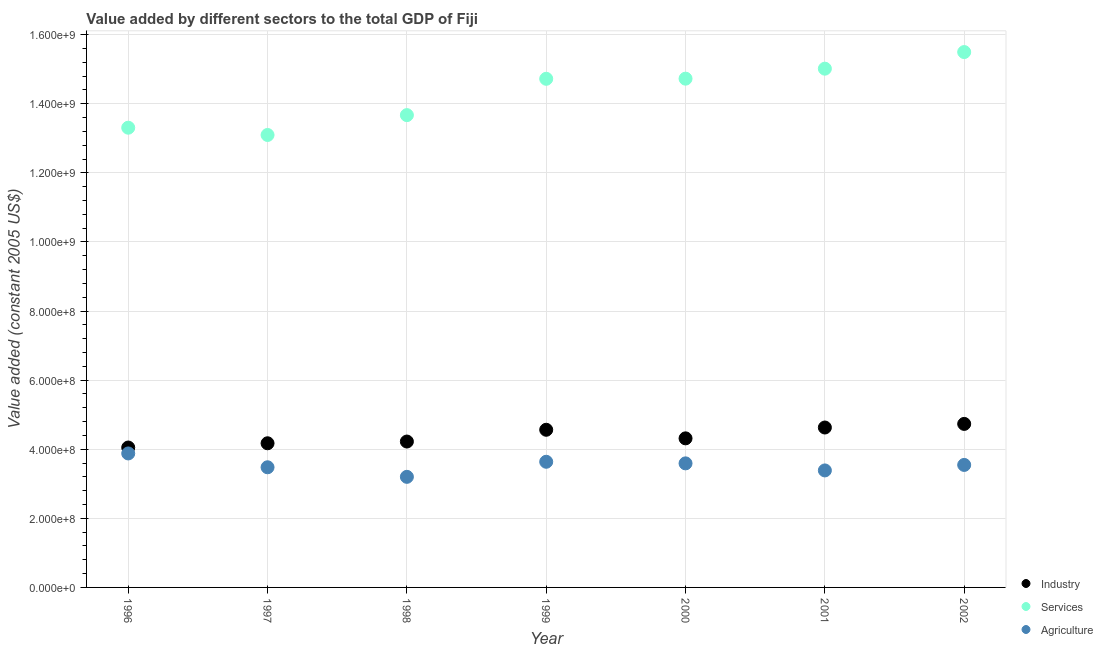How many different coloured dotlines are there?
Give a very brief answer. 3. Is the number of dotlines equal to the number of legend labels?
Offer a very short reply. Yes. What is the value added by services in 2000?
Offer a very short reply. 1.47e+09. Across all years, what is the maximum value added by agricultural sector?
Give a very brief answer. 3.88e+08. Across all years, what is the minimum value added by agricultural sector?
Your answer should be compact. 3.20e+08. In which year was the value added by industrial sector minimum?
Keep it short and to the point. 1996. What is the total value added by services in the graph?
Your answer should be compact. 1.00e+1. What is the difference between the value added by agricultural sector in 1996 and that in 2001?
Provide a short and direct response. 4.91e+07. What is the difference between the value added by services in 1999 and the value added by industrial sector in 2000?
Offer a very short reply. 1.04e+09. What is the average value added by industrial sector per year?
Your answer should be very brief. 4.38e+08. In the year 1999, what is the difference between the value added by industrial sector and value added by services?
Offer a very short reply. -1.02e+09. In how many years, is the value added by services greater than 200000000 US$?
Provide a succinct answer. 7. What is the ratio of the value added by industrial sector in 1996 to that in 2000?
Make the answer very short. 0.94. What is the difference between the highest and the second highest value added by services?
Your answer should be very brief. 4.81e+07. What is the difference between the highest and the lowest value added by industrial sector?
Keep it short and to the point. 6.84e+07. In how many years, is the value added by industrial sector greater than the average value added by industrial sector taken over all years?
Provide a short and direct response. 3. Is the sum of the value added by services in 1998 and 2001 greater than the maximum value added by industrial sector across all years?
Give a very brief answer. Yes. Is the value added by services strictly greater than the value added by agricultural sector over the years?
Provide a succinct answer. Yes. How many years are there in the graph?
Give a very brief answer. 7. What is the difference between two consecutive major ticks on the Y-axis?
Keep it short and to the point. 2.00e+08. Are the values on the major ticks of Y-axis written in scientific E-notation?
Your response must be concise. Yes. Does the graph contain grids?
Make the answer very short. Yes. Where does the legend appear in the graph?
Provide a succinct answer. Bottom right. How many legend labels are there?
Your answer should be very brief. 3. How are the legend labels stacked?
Make the answer very short. Vertical. What is the title of the graph?
Your response must be concise. Value added by different sectors to the total GDP of Fiji. What is the label or title of the Y-axis?
Provide a succinct answer. Value added (constant 2005 US$). What is the Value added (constant 2005 US$) in Industry in 1996?
Your response must be concise. 4.05e+08. What is the Value added (constant 2005 US$) in Services in 1996?
Your answer should be compact. 1.33e+09. What is the Value added (constant 2005 US$) in Agriculture in 1996?
Ensure brevity in your answer.  3.88e+08. What is the Value added (constant 2005 US$) in Industry in 1997?
Your response must be concise. 4.17e+08. What is the Value added (constant 2005 US$) of Services in 1997?
Keep it short and to the point. 1.31e+09. What is the Value added (constant 2005 US$) in Agriculture in 1997?
Offer a very short reply. 3.48e+08. What is the Value added (constant 2005 US$) of Industry in 1998?
Your response must be concise. 4.22e+08. What is the Value added (constant 2005 US$) of Services in 1998?
Offer a very short reply. 1.37e+09. What is the Value added (constant 2005 US$) in Agriculture in 1998?
Give a very brief answer. 3.20e+08. What is the Value added (constant 2005 US$) in Industry in 1999?
Ensure brevity in your answer.  4.56e+08. What is the Value added (constant 2005 US$) of Services in 1999?
Offer a terse response. 1.47e+09. What is the Value added (constant 2005 US$) of Agriculture in 1999?
Make the answer very short. 3.64e+08. What is the Value added (constant 2005 US$) of Industry in 2000?
Offer a terse response. 4.31e+08. What is the Value added (constant 2005 US$) in Services in 2000?
Your answer should be very brief. 1.47e+09. What is the Value added (constant 2005 US$) of Agriculture in 2000?
Your response must be concise. 3.59e+08. What is the Value added (constant 2005 US$) of Industry in 2001?
Offer a terse response. 4.63e+08. What is the Value added (constant 2005 US$) in Services in 2001?
Keep it short and to the point. 1.50e+09. What is the Value added (constant 2005 US$) of Agriculture in 2001?
Make the answer very short. 3.39e+08. What is the Value added (constant 2005 US$) of Industry in 2002?
Provide a succinct answer. 4.73e+08. What is the Value added (constant 2005 US$) in Services in 2002?
Ensure brevity in your answer.  1.55e+09. What is the Value added (constant 2005 US$) in Agriculture in 2002?
Provide a short and direct response. 3.55e+08. Across all years, what is the maximum Value added (constant 2005 US$) of Industry?
Offer a very short reply. 4.73e+08. Across all years, what is the maximum Value added (constant 2005 US$) in Services?
Your answer should be compact. 1.55e+09. Across all years, what is the maximum Value added (constant 2005 US$) in Agriculture?
Give a very brief answer. 3.88e+08. Across all years, what is the minimum Value added (constant 2005 US$) in Industry?
Provide a short and direct response. 4.05e+08. Across all years, what is the minimum Value added (constant 2005 US$) in Services?
Offer a terse response. 1.31e+09. Across all years, what is the minimum Value added (constant 2005 US$) of Agriculture?
Offer a terse response. 3.20e+08. What is the total Value added (constant 2005 US$) in Industry in the graph?
Provide a succinct answer. 3.07e+09. What is the total Value added (constant 2005 US$) in Services in the graph?
Offer a very short reply. 1.00e+1. What is the total Value added (constant 2005 US$) of Agriculture in the graph?
Your response must be concise. 2.47e+09. What is the difference between the Value added (constant 2005 US$) of Industry in 1996 and that in 1997?
Give a very brief answer. -1.23e+07. What is the difference between the Value added (constant 2005 US$) in Services in 1996 and that in 1997?
Offer a terse response. 2.11e+07. What is the difference between the Value added (constant 2005 US$) in Agriculture in 1996 and that in 1997?
Your answer should be compact. 4.00e+07. What is the difference between the Value added (constant 2005 US$) of Industry in 1996 and that in 1998?
Offer a terse response. -1.73e+07. What is the difference between the Value added (constant 2005 US$) in Services in 1996 and that in 1998?
Provide a succinct answer. -3.64e+07. What is the difference between the Value added (constant 2005 US$) of Agriculture in 1996 and that in 1998?
Your response must be concise. 6.77e+07. What is the difference between the Value added (constant 2005 US$) of Industry in 1996 and that in 1999?
Your answer should be very brief. -5.14e+07. What is the difference between the Value added (constant 2005 US$) in Services in 1996 and that in 1999?
Provide a succinct answer. -1.42e+08. What is the difference between the Value added (constant 2005 US$) in Agriculture in 1996 and that in 1999?
Your response must be concise. 2.41e+07. What is the difference between the Value added (constant 2005 US$) in Industry in 1996 and that in 2000?
Your response must be concise. -2.65e+07. What is the difference between the Value added (constant 2005 US$) in Services in 1996 and that in 2000?
Provide a succinct answer. -1.42e+08. What is the difference between the Value added (constant 2005 US$) of Agriculture in 1996 and that in 2000?
Provide a short and direct response. 2.87e+07. What is the difference between the Value added (constant 2005 US$) of Industry in 1996 and that in 2001?
Offer a very short reply. -5.79e+07. What is the difference between the Value added (constant 2005 US$) in Services in 1996 and that in 2001?
Provide a short and direct response. -1.71e+08. What is the difference between the Value added (constant 2005 US$) in Agriculture in 1996 and that in 2001?
Keep it short and to the point. 4.91e+07. What is the difference between the Value added (constant 2005 US$) of Industry in 1996 and that in 2002?
Make the answer very short. -6.84e+07. What is the difference between the Value added (constant 2005 US$) of Services in 1996 and that in 2002?
Make the answer very short. -2.19e+08. What is the difference between the Value added (constant 2005 US$) of Agriculture in 1996 and that in 2002?
Offer a very short reply. 3.32e+07. What is the difference between the Value added (constant 2005 US$) in Industry in 1997 and that in 1998?
Your answer should be compact. -5.03e+06. What is the difference between the Value added (constant 2005 US$) of Services in 1997 and that in 1998?
Provide a short and direct response. -5.75e+07. What is the difference between the Value added (constant 2005 US$) in Agriculture in 1997 and that in 1998?
Give a very brief answer. 2.77e+07. What is the difference between the Value added (constant 2005 US$) in Industry in 1997 and that in 1999?
Provide a short and direct response. -3.91e+07. What is the difference between the Value added (constant 2005 US$) in Services in 1997 and that in 1999?
Give a very brief answer. -1.63e+08. What is the difference between the Value added (constant 2005 US$) in Agriculture in 1997 and that in 1999?
Make the answer very short. -1.59e+07. What is the difference between the Value added (constant 2005 US$) in Industry in 1997 and that in 2000?
Your answer should be compact. -1.42e+07. What is the difference between the Value added (constant 2005 US$) of Services in 1997 and that in 2000?
Give a very brief answer. -1.63e+08. What is the difference between the Value added (constant 2005 US$) of Agriculture in 1997 and that in 2000?
Your answer should be compact. -1.13e+07. What is the difference between the Value added (constant 2005 US$) in Industry in 1997 and that in 2001?
Make the answer very short. -4.56e+07. What is the difference between the Value added (constant 2005 US$) of Services in 1997 and that in 2001?
Provide a succinct answer. -1.92e+08. What is the difference between the Value added (constant 2005 US$) of Agriculture in 1997 and that in 2001?
Your response must be concise. 9.13e+06. What is the difference between the Value added (constant 2005 US$) in Industry in 1997 and that in 2002?
Your response must be concise. -5.61e+07. What is the difference between the Value added (constant 2005 US$) in Services in 1997 and that in 2002?
Ensure brevity in your answer.  -2.40e+08. What is the difference between the Value added (constant 2005 US$) of Agriculture in 1997 and that in 2002?
Give a very brief answer. -6.79e+06. What is the difference between the Value added (constant 2005 US$) of Industry in 1998 and that in 1999?
Give a very brief answer. -3.41e+07. What is the difference between the Value added (constant 2005 US$) in Services in 1998 and that in 1999?
Offer a very short reply. -1.05e+08. What is the difference between the Value added (constant 2005 US$) in Agriculture in 1998 and that in 1999?
Make the answer very short. -4.36e+07. What is the difference between the Value added (constant 2005 US$) of Industry in 1998 and that in 2000?
Offer a very short reply. -9.22e+06. What is the difference between the Value added (constant 2005 US$) of Services in 1998 and that in 2000?
Keep it short and to the point. -1.06e+08. What is the difference between the Value added (constant 2005 US$) in Agriculture in 1998 and that in 2000?
Keep it short and to the point. -3.90e+07. What is the difference between the Value added (constant 2005 US$) in Industry in 1998 and that in 2001?
Provide a succinct answer. -4.06e+07. What is the difference between the Value added (constant 2005 US$) in Services in 1998 and that in 2001?
Your answer should be very brief. -1.34e+08. What is the difference between the Value added (constant 2005 US$) in Agriculture in 1998 and that in 2001?
Offer a terse response. -1.86e+07. What is the difference between the Value added (constant 2005 US$) in Industry in 1998 and that in 2002?
Provide a succinct answer. -5.10e+07. What is the difference between the Value added (constant 2005 US$) in Services in 1998 and that in 2002?
Your answer should be very brief. -1.83e+08. What is the difference between the Value added (constant 2005 US$) of Agriculture in 1998 and that in 2002?
Keep it short and to the point. -3.45e+07. What is the difference between the Value added (constant 2005 US$) of Industry in 1999 and that in 2000?
Your answer should be compact. 2.48e+07. What is the difference between the Value added (constant 2005 US$) of Services in 1999 and that in 2000?
Offer a very short reply. -3.88e+05. What is the difference between the Value added (constant 2005 US$) in Agriculture in 1999 and that in 2000?
Make the answer very short. 4.60e+06. What is the difference between the Value added (constant 2005 US$) of Industry in 1999 and that in 2001?
Your answer should be very brief. -6.54e+06. What is the difference between the Value added (constant 2005 US$) in Services in 1999 and that in 2001?
Make the answer very short. -2.93e+07. What is the difference between the Value added (constant 2005 US$) of Agriculture in 1999 and that in 2001?
Provide a succinct answer. 2.50e+07. What is the difference between the Value added (constant 2005 US$) in Industry in 1999 and that in 2002?
Your answer should be compact. -1.70e+07. What is the difference between the Value added (constant 2005 US$) of Services in 1999 and that in 2002?
Your response must be concise. -7.74e+07. What is the difference between the Value added (constant 2005 US$) in Agriculture in 1999 and that in 2002?
Provide a succinct answer. 9.13e+06. What is the difference between the Value added (constant 2005 US$) of Industry in 2000 and that in 2001?
Make the answer very short. -3.14e+07. What is the difference between the Value added (constant 2005 US$) in Services in 2000 and that in 2001?
Give a very brief answer. -2.89e+07. What is the difference between the Value added (constant 2005 US$) of Agriculture in 2000 and that in 2001?
Your answer should be very brief. 2.04e+07. What is the difference between the Value added (constant 2005 US$) in Industry in 2000 and that in 2002?
Provide a short and direct response. -4.18e+07. What is the difference between the Value added (constant 2005 US$) in Services in 2000 and that in 2002?
Ensure brevity in your answer.  -7.70e+07. What is the difference between the Value added (constant 2005 US$) of Agriculture in 2000 and that in 2002?
Provide a succinct answer. 4.52e+06. What is the difference between the Value added (constant 2005 US$) of Industry in 2001 and that in 2002?
Offer a terse response. -1.05e+07. What is the difference between the Value added (constant 2005 US$) in Services in 2001 and that in 2002?
Offer a very short reply. -4.81e+07. What is the difference between the Value added (constant 2005 US$) of Agriculture in 2001 and that in 2002?
Offer a very short reply. -1.59e+07. What is the difference between the Value added (constant 2005 US$) in Industry in 1996 and the Value added (constant 2005 US$) in Services in 1997?
Make the answer very short. -9.05e+08. What is the difference between the Value added (constant 2005 US$) of Industry in 1996 and the Value added (constant 2005 US$) of Agriculture in 1997?
Offer a very short reply. 5.72e+07. What is the difference between the Value added (constant 2005 US$) of Services in 1996 and the Value added (constant 2005 US$) of Agriculture in 1997?
Your answer should be very brief. 9.83e+08. What is the difference between the Value added (constant 2005 US$) of Industry in 1996 and the Value added (constant 2005 US$) of Services in 1998?
Provide a short and direct response. -9.62e+08. What is the difference between the Value added (constant 2005 US$) in Industry in 1996 and the Value added (constant 2005 US$) in Agriculture in 1998?
Your answer should be compact. 8.49e+07. What is the difference between the Value added (constant 2005 US$) of Services in 1996 and the Value added (constant 2005 US$) of Agriculture in 1998?
Keep it short and to the point. 1.01e+09. What is the difference between the Value added (constant 2005 US$) of Industry in 1996 and the Value added (constant 2005 US$) of Services in 1999?
Offer a terse response. -1.07e+09. What is the difference between the Value added (constant 2005 US$) of Industry in 1996 and the Value added (constant 2005 US$) of Agriculture in 1999?
Your answer should be very brief. 4.13e+07. What is the difference between the Value added (constant 2005 US$) in Services in 1996 and the Value added (constant 2005 US$) in Agriculture in 1999?
Offer a very short reply. 9.67e+08. What is the difference between the Value added (constant 2005 US$) in Industry in 1996 and the Value added (constant 2005 US$) in Services in 2000?
Provide a short and direct response. -1.07e+09. What is the difference between the Value added (constant 2005 US$) in Industry in 1996 and the Value added (constant 2005 US$) in Agriculture in 2000?
Offer a very short reply. 4.59e+07. What is the difference between the Value added (constant 2005 US$) of Services in 1996 and the Value added (constant 2005 US$) of Agriculture in 2000?
Give a very brief answer. 9.72e+08. What is the difference between the Value added (constant 2005 US$) of Industry in 1996 and the Value added (constant 2005 US$) of Services in 2001?
Ensure brevity in your answer.  -1.10e+09. What is the difference between the Value added (constant 2005 US$) in Industry in 1996 and the Value added (constant 2005 US$) in Agriculture in 2001?
Your answer should be compact. 6.63e+07. What is the difference between the Value added (constant 2005 US$) of Services in 1996 and the Value added (constant 2005 US$) of Agriculture in 2001?
Provide a succinct answer. 9.92e+08. What is the difference between the Value added (constant 2005 US$) in Industry in 1996 and the Value added (constant 2005 US$) in Services in 2002?
Provide a short and direct response. -1.14e+09. What is the difference between the Value added (constant 2005 US$) of Industry in 1996 and the Value added (constant 2005 US$) of Agriculture in 2002?
Offer a very short reply. 5.04e+07. What is the difference between the Value added (constant 2005 US$) of Services in 1996 and the Value added (constant 2005 US$) of Agriculture in 2002?
Ensure brevity in your answer.  9.76e+08. What is the difference between the Value added (constant 2005 US$) of Industry in 1997 and the Value added (constant 2005 US$) of Services in 1998?
Provide a short and direct response. -9.50e+08. What is the difference between the Value added (constant 2005 US$) in Industry in 1997 and the Value added (constant 2005 US$) in Agriculture in 1998?
Provide a short and direct response. 9.72e+07. What is the difference between the Value added (constant 2005 US$) of Services in 1997 and the Value added (constant 2005 US$) of Agriculture in 1998?
Offer a very short reply. 9.90e+08. What is the difference between the Value added (constant 2005 US$) of Industry in 1997 and the Value added (constant 2005 US$) of Services in 1999?
Ensure brevity in your answer.  -1.05e+09. What is the difference between the Value added (constant 2005 US$) in Industry in 1997 and the Value added (constant 2005 US$) in Agriculture in 1999?
Keep it short and to the point. 5.36e+07. What is the difference between the Value added (constant 2005 US$) in Services in 1997 and the Value added (constant 2005 US$) in Agriculture in 1999?
Your answer should be very brief. 9.46e+08. What is the difference between the Value added (constant 2005 US$) of Industry in 1997 and the Value added (constant 2005 US$) of Services in 2000?
Make the answer very short. -1.06e+09. What is the difference between the Value added (constant 2005 US$) of Industry in 1997 and the Value added (constant 2005 US$) of Agriculture in 2000?
Make the answer very short. 5.82e+07. What is the difference between the Value added (constant 2005 US$) in Services in 1997 and the Value added (constant 2005 US$) in Agriculture in 2000?
Provide a short and direct response. 9.51e+08. What is the difference between the Value added (constant 2005 US$) of Industry in 1997 and the Value added (constant 2005 US$) of Services in 2001?
Keep it short and to the point. -1.08e+09. What is the difference between the Value added (constant 2005 US$) of Industry in 1997 and the Value added (constant 2005 US$) of Agriculture in 2001?
Keep it short and to the point. 7.86e+07. What is the difference between the Value added (constant 2005 US$) of Services in 1997 and the Value added (constant 2005 US$) of Agriculture in 2001?
Provide a succinct answer. 9.71e+08. What is the difference between the Value added (constant 2005 US$) in Industry in 1997 and the Value added (constant 2005 US$) in Services in 2002?
Provide a succinct answer. -1.13e+09. What is the difference between the Value added (constant 2005 US$) of Industry in 1997 and the Value added (constant 2005 US$) of Agriculture in 2002?
Provide a short and direct response. 6.27e+07. What is the difference between the Value added (constant 2005 US$) in Services in 1997 and the Value added (constant 2005 US$) in Agriculture in 2002?
Your answer should be compact. 9.55e+08. What is the difference between the Value added (constant 2005 US$) in Industry in 1998 and the Value added (constant 2005 US$) in Services in 1999?
Make the answer very short. -1.05e+09. What is the difference between the Value added (constant 2005 US$) of Industry in 1998 and the Value added (constant 2005 US$) of Agriculture in 1999?
Provide a succinct answer. 5.86e+07. What is the difference between the Value added (constant 2005 US$) in Services in 1998 and the Value added (constant 2005 US$) in Agriculture in 1999?
Your answer should be very brief. 1.00e+09. What is the difference between the Value added (constant 2005 US$) of Industry in 1998 and the Value added (constant 2005 US$) of Services in 2000?
Make the answer very short. -1.05e+09. What is the difference between the Value added (constant 2005 US$) of Industry in 1998 and the Value added (constant 2005 US$) of Agriculture in 2000?
Your answer should be compact. 6.32e+07. What is the difference between the Value added (constant 2005 US$) in Services in 1998 and the Value added (constant 2005 US$) in Agriculture in 2000?
Ensure brevity in your answer.  1.01e+09. What is the difference between the Value added (constant 2005 US$) in Industry in 1998 and the Value added (constant 2005 US$) in Services in 2001?
Provide a short and direct response. -1.08e+09. What is the difference between the Value added (constant 2005 US$) of Industry in 1998 and the Value added (constant 2005 US$) of Agriculture in 2001?
Give a very brief answer. 8.36e+07. What is the difference between the Value added (constant 2005 US$) of Services in 1998 and the Value added (constant 2005 US$) of Agriculture in 2001?
Your answer should be very brief. 1.03e+09. What is the difference between the Value added (constant 2005 US$) in Industry in 1998 and the Value added (constant 2005 US$) in Services in 2002?
Ensure brevity in your answer.  -1.13e+09. What is the difference between the Value added (constant 2005 US$) in Industry in 1998 and the Value added (constant 2005 US$) in Agriculture in 2002?
Make the answer very short. 6.77e+07. What is the difference between the Value added (constant 2005 US$) of Services in 1998 and the Value added (constant 2005 US$) of Agriculture in 2002?
Offer a very short reply. 1.01e+09. What is the difference between the Value added (constant 2005 US$) in Industry in 1999 and the Value added (constant 2005 US$) in Services in 2000?
Give a very brief answer. -1.02e+09. What is the difference between the Value added (constant 2005 US$) in Industry in 1999 and the Value added (constant 2005 US$) in Agriculture in 2000?
Keep it short and to the point. 9.72e+07. What is the difference between the Value added (constant 2005 US$) of Services in 1999 and the Value added (constant 2005 US$) of Agriculture in 2000?
Give a very brief answer. 1.11e+09. What is the difference between the Value added (constant 2005 US$) of Industry in 1999 and the Value added (constant 2005 US$) of Services in 2001?
Keep it short and to the point. -1.05e+09. What is the difference between the Value added (constant 2005 US$) in Industry in 1999 and the Value added (constant 2005 US$) in Agriculture in 2001?
Ensure brevity in your answer.  1.18e+08. What is the difference between the Value added (constant 2005 US$) of Services in 1999 and the Value added (constant 2005 US$) of Agriculture in 2001?
Offer a very short reply. 1.13e+09. What is the difference between the Value added (constant 2005 US$) in Industry in 1999 and the Value added (constant 2005 US$) in Services in 2002?
Offer a very short reply. -1.09e+09. What is the difference between the Value added (constant 2005 US$) of Industry in 1999 and the Value added (constant 2005 US$) of Agriculture in 2002?
Your answer should be very brief. 1.02e+08. What is the difference between the Value added (constant 2005 US$) in Services in 1999 and the Value added (constant 2005 US$) in Agriculture in 2002?
Give a very brief answer. 1.12e+09. What is the difference between the Value added (constant 2005 US$) of Industry in 2000 and the Value added (constant 2005 US$) of Services in 2001?
Your answer should be very brief. -1.07e+09. What is the difference between the Value added (constant 2005 US$) in Industry in 2000 and the Value added (constant 2005 US$) in Agriculture in 2001?
Your answer should be compact. 9.28e+07. What is the difference between the Value added (constant 2005 US$) in Services in 2000 and the Value added (constant 2005 US$) in Agriculture in 2001?
Your answer should be very brief. 1.13e+09. What is the difference between the Value added (constant 2005 US$) of Industry in 2000 and the Value added (constant 2005 US$) of Services in 2002?
Offer a terse response. -1.12e+09. What is the difference between the Value added (constant 2005 US$) in Industry in 2000 and the Value added (constant 2005 US$) in Agriculture in 2002?
Offer a terse response. 7.69e+07. What is the difference between the Value added (constant 2005 US$) of Services in 2000 and the Value added (constant 2005 US$) of Agriculture in 2002?
Give a very brief answer. 1.12e+09. What is the difference between the Value added (constant 2005 US$) in Industry in 2001 and the Value added (constant 2005 US$) in Services in 2002?
Provide a succinct answer. -1.09e+09. What is the difference between the Value added (constant 2005 US$) in Industry in 2001 and the Value added (constant 2005 US$) in Agriculture in 2002?
Offer a very short reply. 1.08e+08. What is the difference between the Value added (constant 2005 US$) of Services in 2001 and the Value added (constant 2005 US$) of Agriculture in 2002?
Keep it short and to the point. 1.15e+09. What is the average Value added (constant 2005 US$) in Industry per year?
Make the answer very short. 4.38e+08. What is the average Value added (constant 2005 US$) in Services per year?
Make the answer very short. 1.43e+09. What is the average Value added (constant 2005 US$) of Agriculture per year?
Provide a short and direct response. 3.53e+08. In the year 1996, what is the difference between the Value added (constant 2005 US$) of Industry and Value added (constant 2005 US$) of Services?
Give a very brief answer. -9.26e+08. In the year 1996, what is the difference between the Value added (constant 2005 US$) in Industry and Value added (constant 2005 US$) in Agriculture?
Offer a very short reply. 1.72e+07. In the year 1996, what is the difference between the Value added (constant 2005 US$) in Services and Value added (constant 2005 US$) in Agriculture?
Provide a succinct answer. 9.43e+08. In the year 1997, what is the difference between the Value added (constant 2005 US$) in Industry and Value added (constant 2005 US$) in Services?
Give a very brief answer. -8.92e+08. In the year 1997, what is the difference between the Value added (constant 2005 US$) in Industry and Value added (constant 2005 US$) in Agriculture?
Provide a succinct answer. 6.95e+07. In the year 1997, what is the difference between the Value added (constant 2005 US$) in Services and Value added (constant 2005 US$) in Agriculture?
Your response must be concise. 9.62e+08. In the year 1998, what is the difference between the Value added (constant 2005 US$) of Industry and Value added (constant 2005 US$) of Services?
Offer a very short reply. -9.45e+08. In the year 1998, what is the difference between the Value added (constant 2005 US$) in Industry and Value added (constant 2005 US$) in Agriculture?
Offer a very short reply. 1.02e+08. In the year 1998, what is the difference between the Value added (constant 2005 US$) in Services and Value added (constant 2005 US$) in Agriculture?
Your answer should be compact. 1.05e+09. In the year 1999, what is the difference between the Value added (constant 2005 US$) in Industry and Value added (constant 2005 US$) in Services?
Provide a succinct answer. -1.02e+09. In the year 1999, what is the difference between the Value added (constant 2005 US$) in Industry and Value added (constant 2005 US$) in Agriculture?
Offer a very short reply. 9.26e+07. In the year 1999, what is the difference between the Value added (constant 2005 US$) in Services and Value added (constant 2005 US$) in Agriculture?
Your response must be concise. 1.11e+09. In the year 2000, what is the difference between the Value added (constant 2005 US$) of Industry and Value added (constant 2005 US$) of Services?
Your answer should be very brief. -1.04e+09. In the year 2000, what is the difference between the Value added (constant 2005 US$) in Industry and Value added (constant 2005 US$) in Agriculture?
Give a very brief answer. 7.24e+07. In the year 2000, what is the difference between the Value added (constant 2005 US$) of Services and Value added (constant 2005 US$) of Agriculture?
Provide a short and direct response. 1.11e+09. In the year 2001, what is the difference between the Value added (constant 2005 US$) in Industry and Value added (constant 2005 US$) in Services?
Your response must be concise. -1.04e+09. In the year 2001, what is the difference between the Value added (constant 2005 US$) in Industry and Value added (constant 2005 US$) in Agriculture?
Make the answer very short. 1.24e+08. In the year 2001, what is the difference between the Value added (constant 2005 US$) in Services and Value added (constant 2005 US$) in Agriculture?
Ensure brevity in your answer.  1.16e+09. In the year 2002, what is the difference between the Value added (constant 2005 US$) of Industry and Value added (constant 2005 US$) of Services?
Provide a short and direct response. -1.08e+09. In the year 2002, what is the difference between the Value added (constant 2005 US$) of Industry and Value added (constant 2005 US$) of Agriculture?
Offer a terse response. 1.19e+08. In the year 2002, what is the difference between the Value added (constant 2005 US$) of Services and Value added (constant 2005 US$) of Agriculture?
Offer a very short reply. 1.20e+09. What is the ratio of the Value added (constant 2005 US$) in Industry in 1996 to that in 1997?
Your response must be concise. 0.97. What is the ratio of the Value added (constant 2005 US$) of Services in 1996 to that in 1997?
Make the answer very short. 1.02. What is the ratio of the Value added (constant 2005 US$) of Agriculture in 1996 to that in 1997?
Provide a succinct answer. 1.12. What is the ratio of the Value added (constant 2005 US$) in Industry in 1996 to that in 1998?
Ensure brevity in your answer.  0.96. What is the ratio of the Value added (constant 2005 US$) of Services in 1996 to that in 1998?
Make the answer very short. 0.97. What is the ratio of the Value added (constant 2005 US$) in Agriculture in 1996 to that in 1998?
Give a very brief answer. 1.21. What is the ratio of the Value added (constant 2005 US$) of Industry in 1996 to that in 1999?
Keep it short and to the point. 0.89. What is the ratio of the Value added (constant 2005 US$) in Services in 1996 to that in 1999?
Your response must be concise. 0.9. What is the ratio of the Value added (constant 2005 US$) in Agriculture in 1996 to that in 1999?
Make the answer very short. 1.07. What is the ratio of the Value added (constant 2005 US$) of Industry in 1996 to that in 2000?
Offer a terse response. 0.94. What is the ratio of the Value added (constant 2005 US$) of Services in 1996 to that in 2000?
Provide a short and direct response. 0.9. What is the ratio of the Value added (constant 2005 US$) of Agriculture in 1996 to that in 2000?
Provide a short and direct response. 1.08. What is the ratio of the Value added (constant 2005 US$) in Industry in 1996 to that in 2001?
Provide a succinct answer. 0.87. What is the ratio of the Value added (constant 2005 US$) in Services in 1996 to that in 2001?
Offer a very short reply. 0.89. What is the ratio of the Value added (constant 2005 US$) of Agriculture in 1996 to that in 2001?
Offer a terse response. 1.15. What is the ratio of the Value added (constant 2005 US$) of Industry in 1996 to that in 2002?
Ensure brevity in your answer.  0.86. What is the ratio of the Value added (constant 2005 US$) in Services in 1996 to that in 2002?
Keep it short and to the point. 0.86. What is the ratio of the Value added (constant 2005 US$) in Agriculture in 1996 to that in 2002?
Offer a very short reply. 1.09. What is the ratio of the Value added (constant 2005 US$) in Services in 1997 to that in 1998?
Ensure brevity in your answer.  0.96. What is the ratio of the Value added (constant 2005 US$) in Agriculture in 1997 to that in 1998?
Make the answer very short. 1.09. What is the ratio of the Value added (constant 2005 US$) of Industry in 1997 to that in 1999?
Offer a very short reply. 0.91. What is the ratio of the Value added (constant 2005 US$) of Services in 1997 to that in 1999?
Make the answer very short. 0.89. What is the ratio of the Value added (constant 2005 US$) in Agriculture in 1997 to that in 1999?
Ensure brevity in your answer.  0.96. What is the ratio of the Value added (constant 2005 US$) of Services in 1997 to that in 2000?
Offer a very short reply. 0.89. What is the ratio of the Value added (constant 2005 US$) of Agriculture in 1997 to that in 2000?
Give a very brief answer. 0.97. What is the ratio of the Value added (constant 2005 US$) of Industry in 1997 to that in 2001?
Offer a very short reply. 0.9. What is the ratio of the Value added (constant 2005 US$) of Services in 1997 to that in 2001?
Your response must be concise. 0.87. What is the ratio of the Value added (constant 2005 US$) of Industry in 1997 to that in 2002?
Offer a very short reply. 0.88. What is the ratio of the Value added (constant 2005 US$) of Services in 1997 to that in 2002?
Provide a succinct answer. 0.85. What is the ratio of the Value added (constant 2005 US$) of Agriculture in 1997 to that in 2002?
Keep it short and to the point. 0.98. What is the ratio of the Value added (constant 2005 US$) of Industry in 1998 to that in 1999?
Give a very brief answer. 0.93. What is the ratio of the Value added (constant 2005 US$) in Services in 1998 to that in 1999?
Ensure brevity in your answer.  0.93. What is the ratio of the Value added (constant 2005 US$) in Agriculture in 1998 to that in 1999?
Provide a short and direct response. 0.88. What is the ratio of the Value added (constant 2005 US$) in Industry in 1998 to that in 2000?
Provide a short and direct response. 0.98. What is the ratio of the Value added (constant 2005 US$) of Services in 1998 to that in 2000?
Ensure brevity in your answer.  0.93. What is the ratio of the Value added (constant 2005 US$) in Agriculture in 1998 to that in 2000?
Offer a very short reply. 0.89. What is the ratio of the Value added (constant 2005 US$) of Industry in 1998 to that in 2001?
Your answer should be compact. 0.91. What is the ratio of the Value added (constant 2005 US$) in Services in 1998 to that in 2001?
Give a very brief answer. 0.91. What is the ratio of the Value added (constant 2005 US$) in Agriculture in 1998 to that in 2001?
Your answer should be very brief. 0.95. What is the ratio of the Value added (constant 2005 US$) in Industry in 1998 to that in 2002?
Give a very brief answer. 0.89. What is the ratio of the Value added (constant 2005 US$) of Services in 1998 to that in 2002?
Provide a short and direct response. 0.88. What is the ratio of the Value added (constant 2005 US$) of Agriculture in 1998 to that in 2002?
Provide a short and direct response. 0.9. What is the ratio of the Value added (constant 2005 US$) in Industry in 1999 to that in 2000?
Ensure brevity in your answer.  1.06. What is the ratio of the Value added (constant 2005 US$) in Agriculture in 1999 to that in 2000?
Keep it short and to the point. 1.01. What is the ratio of the Value added (constant 2005 US$) of Industry in 1999 to that in 2001?
Keep it short and to the point. 0.99. What is the ratio of the Value added (constant 2005 US$) of Services in 1999 to that in 2001?
Offer a terse response. 0.98. What is the ratio of the Value added (constant 2005 US$) of Agriculture in 1999 to that in 2001?
Your response must be concise. 1.07. What is the ratio of the Value added (constant 2005 US$) in Industry in 1999 to that in 2002?
Offer a very short reply. 0.96. What is the ratio of the Value added (constant 2005 US$) in Services in 1999 to that in 2002?
Keep it short and to the point. 0.95. What is the ratio of the Value added (constant 2005 US$) in Agriculture in 1999 to that in 2002?
Provide a succinct answer. 1.03. What is the ratio of the Value added (constant 2005 US$) in Industry in 2000 to that in 2001?
Give a very brief answer. 0.93. What is the ratio of the Value added (constant 2005 US$) in Services in 2000 to that in 2001?
Your response must be concise. 0.98. What is the ratio of the Value added (constant 2005 US$) in Agriculture in 2000 to that in 2001?
Give a very brief answer. 1.06. What is the ratio of the Value added (constant 2005 US$) of Industry in 2000 to that in 2002?
Offer a very short reply. 0.91. What is the ratio of the Value added (constant 2005 US$) in Services in 2000 to that in 2002?
Your response must be concise. 0.95. What is the ratio of the Value added (constant 2005 US$) in Agriculture in 2000 to that in 2002?
Provide a short and direct response. 1.01. What is the ratio of the Value added (constant 2005 US$) of Industry in 2001 to that in 2002?
Your answer should be compact. 0.98. What is the ratio of the Value added (constant 2005 US$) of Services in 2001 to that in 2002?
Offer a very short reply. 0.97. What is the ratio of the Value added (constant 2005 US$) in Agriculture in 2001 to that in 2002?
Your response must be concise. 0.96. What is the difference between the highest and the second highest Value added (constant 2005 US$) in Industry?
Provide a succinct answer. 1.05e+07. What is the difference between the highest and the second highest Value added (constant 2005 US$) of Services?
Ensure brevity in your answer.  4.81e+07. What is the difference between the highest and the second highest Value added (constant 2005 US$) in Agriculture?
Your answer should be compact. 2.41e+07. What is the difference between the highest and the lowest Value added (constant 2005 US$) of Industry?
Provide a succinct answer. 6.84e+07. What is the difference between the highest and the lowest Value added (constant 2005 US$) of Services?
Offer a very short reply. 2.40e+08. What is the difference between the highest and the lowest Value added (constant 2005 US$) in Agriculture?
Your answer should be very brief. 6.77e+07. 